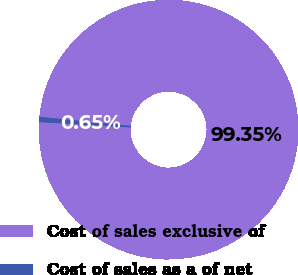<chart> <loc_0><loc_0><loc_500><loc_500><pie_chart><fcel>Cost of sales exclusive of<fcel>Cost of sales as a of net<nl><fcel>99.35%<fcel>0.65%<nl></chart> 